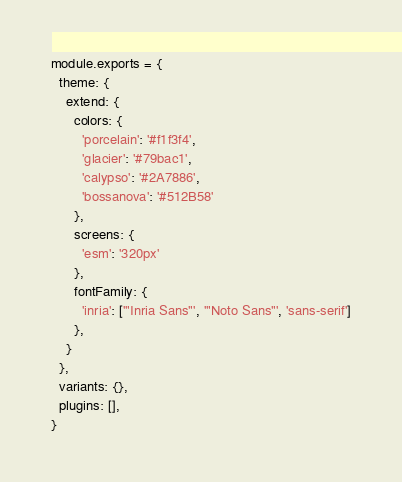<code> <loc_0><loc_0><loc_500><loc_500><_JavaScript_>module.exports = {
  theme: {
    extend: {
      colors: {
        'porcelain': '#f1f3f4',
        'glacier': '#79bac1',
        'calypso': '#2A7886',
        'bossanova': '#512B58'
      },
      screens: {
        'esm': '320px'
      },
      fontFamily: {
        'inria': ['"Inria Sans"', '"Noto Sans"', 'sans-serif']
      },
    }
  },
  variants: {},
  plugins: [],
}</code> 